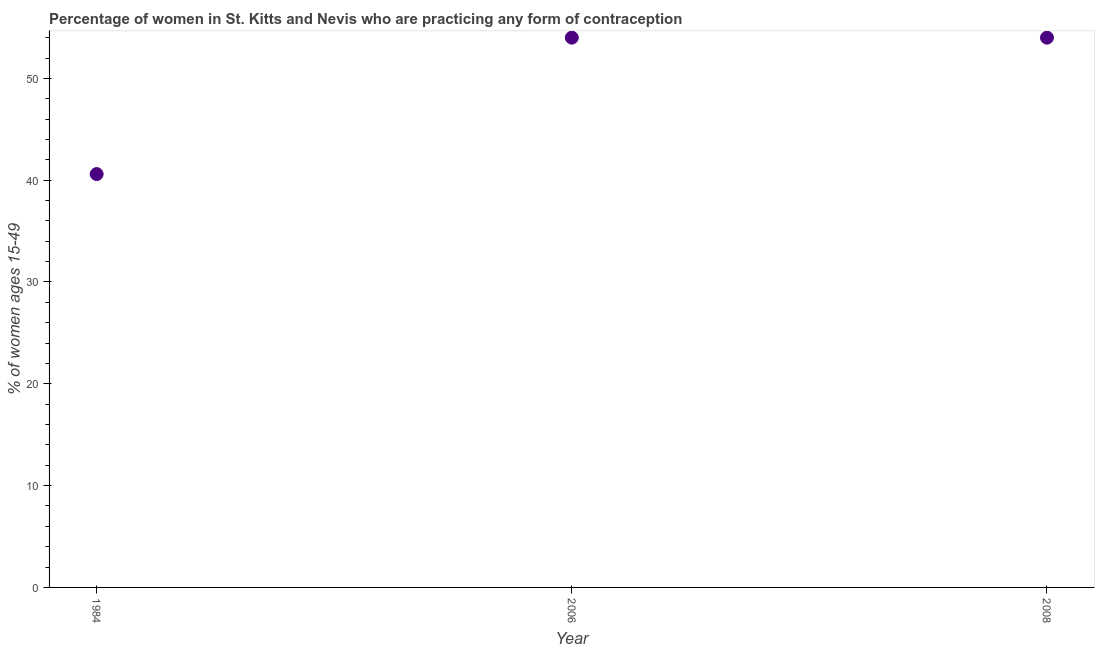What is the contraceptive prevalence in 1984?
Your answer should be very brief. 40.6. Across all years, what is the minimum contraceptive prevalence?
Your answer should be very brief. 40.6. In which year was the contraceptive prevalence minimum?
Your answer should be compact. 1984. What is the sum of the contraceptive prevalence?
Give a very brief answer. 148.6. What is the difference between the contraceptive prevalence in 2006 and 2008?
Offer a terse response. 0. What is the average contraceptive prevalence per year?
Provide a succinct answer. 49.53. What is the median contraceptive prevalence?
Give a very brief answer. 54. In how many years, is the contraceptive prevalence greater than 18 %?
Your response must be concise. 3. Do a majority of the years between 1984 and 2008 (inclusive) have contraceptive prevalence greater than 16 %?
Ensure brevity in your answer.  Yes. What is the ratio of the contraceptive prevalence in 1984 to that in 2006?
Give a very brief answer. 0.75. Is the difference between the contraceptive prevalence in 1984 and 2008 greater than the difference between any two years?
Offer a very short reply. Yes. What is the difference between the highest and the second highest contraceptive prevalence?
Keep it short and to the point. 0. Is the sum of the contraceptive prevalence in 1984 and 2008 greater than the maximum contraceptive prevalence across all years?
Offer a very short reply. Yes. What is the difference between the highest and the lowest contraceptive prevalence?
Your response must be concise. 13.4. In how many years, is the contraceptive prevalence greater than the average contraceptive prevalence taken over all years?
Make the answer very short. 2. Does the contraceptive prevalence monotonically increase over the years?
Your response must be concise. No. How many dotlines are there?
Provide a succinct answer. 1. What is the title of the graph?
Provide a succinct answer. Percentage of women in St. Kitts and Nevis who are practicing any form of contraception. What is the label or title of the X-axis?
Your answer should be very brief. Year. What is the label or title of the Y-axis?
Provide a succinct answer. % of women ages 15-49. What is the % of women ages 15-49 in 1984?
Give a very brief answer. 40.6. What is the % of women ages 15-49 in 2006?
Offer a very short reply. 54. What is the % of women ages 15-49 in 2008?
Provide a short and direct response. 54. What is the difference between the % of women ages 15-49 in 1984 and 2006?
Your response must be concise. -13.4. What is the difference between the % of women ages 15-49 in 2006 and 2008?
Provide a short and direct response. 0. What is the ratio of the % of women ages 15-49 in 1984 to that in 2006?
Your answer should be compact. 0.75. What is the ratio of the % of women ages 15-49 in 1984 to that in 2008?
Provide a short and direct response. 0.75. 